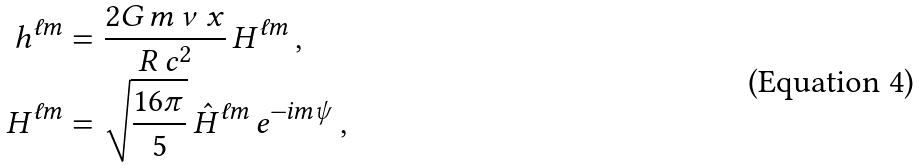Convert formula to latex. <formula><loc_0><loc_0><loc_500><loc_500>h ^ { \ell m } & = \frac { 2 G \, m \, \nu \, x } { R \, c ^ { 2 } } \, H ^ { \ell m } \, , \\ H ^ { \ell m } & = \sqrt { \frac { 1 6 \pi } { 5 } } \, \hat { H } ^ { \ell m } \, e ^ { - i m \psi } \, ,</formula> 